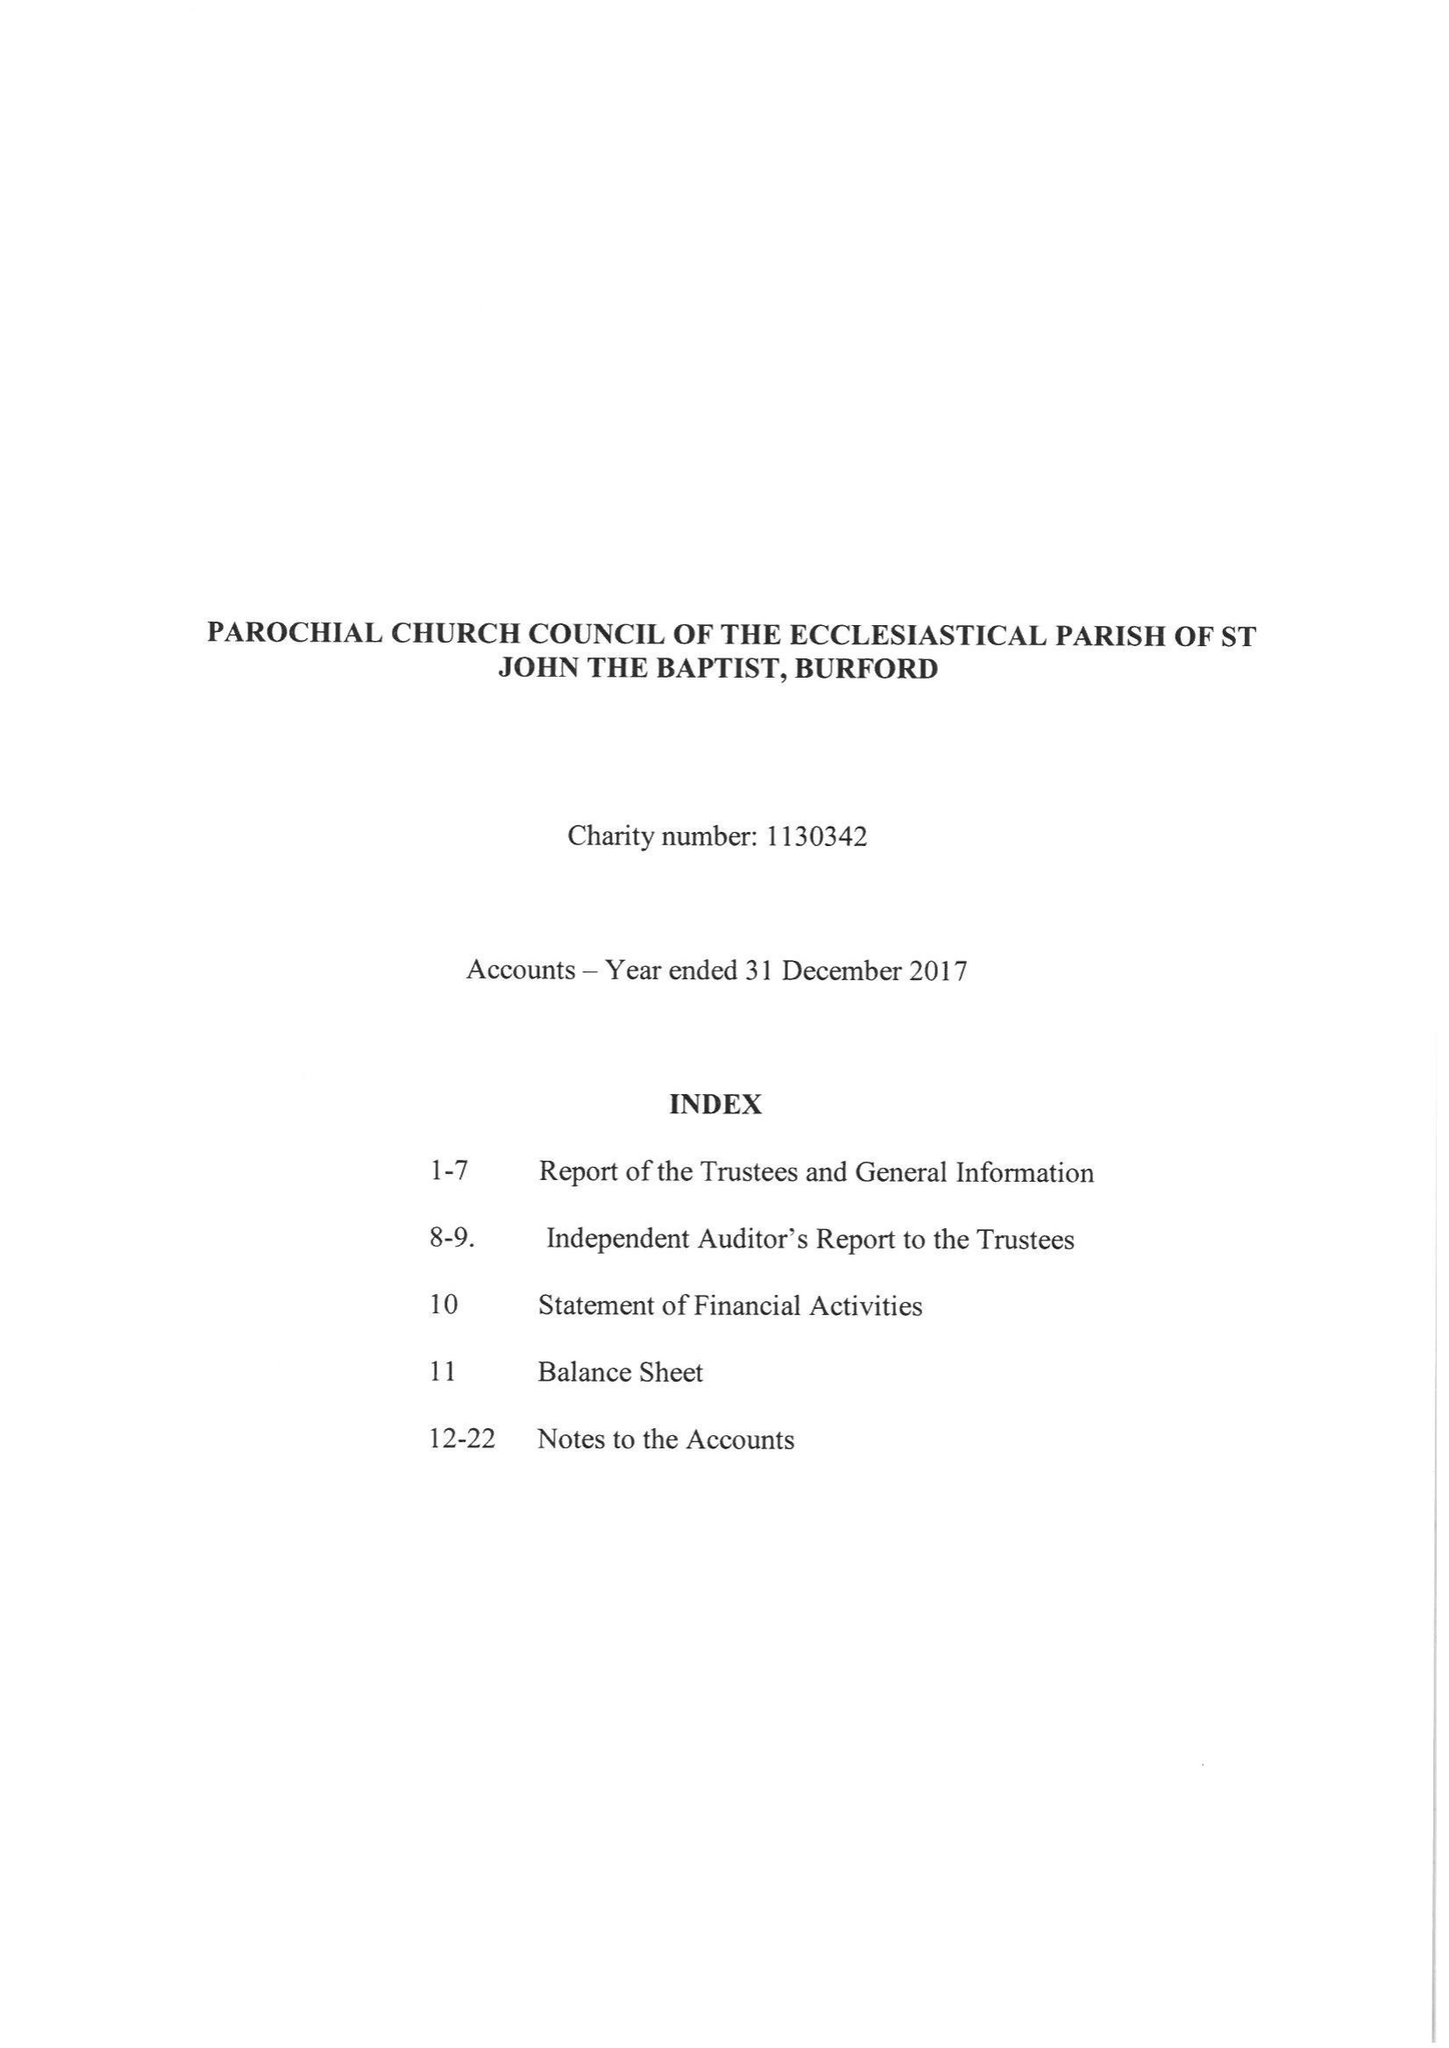What is the value for the address__post_town?
Answer the question using a single word or phrase. CARTERTON 